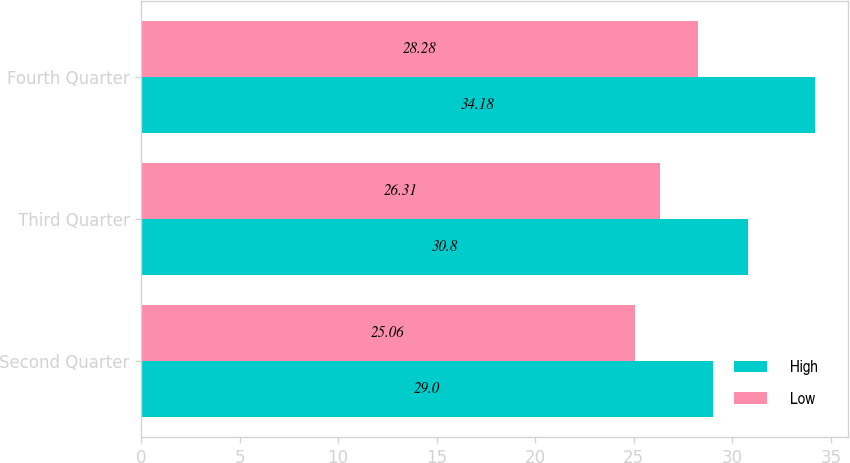Convert chart to OTSL. <chart><loc_0><loc_0><loc_500><loc_500><stacked_bar_chart><ecel><fcel>Second Quarter<fcel>Third Quarter<fcel>Fourth Quarter<nl><fcel>High<fcel>29<fcel>30.8<fcel>34.18<nl><fcel>Low<fcel>25.06<fcel>26.31<fcel>28.28<nl></chart> 